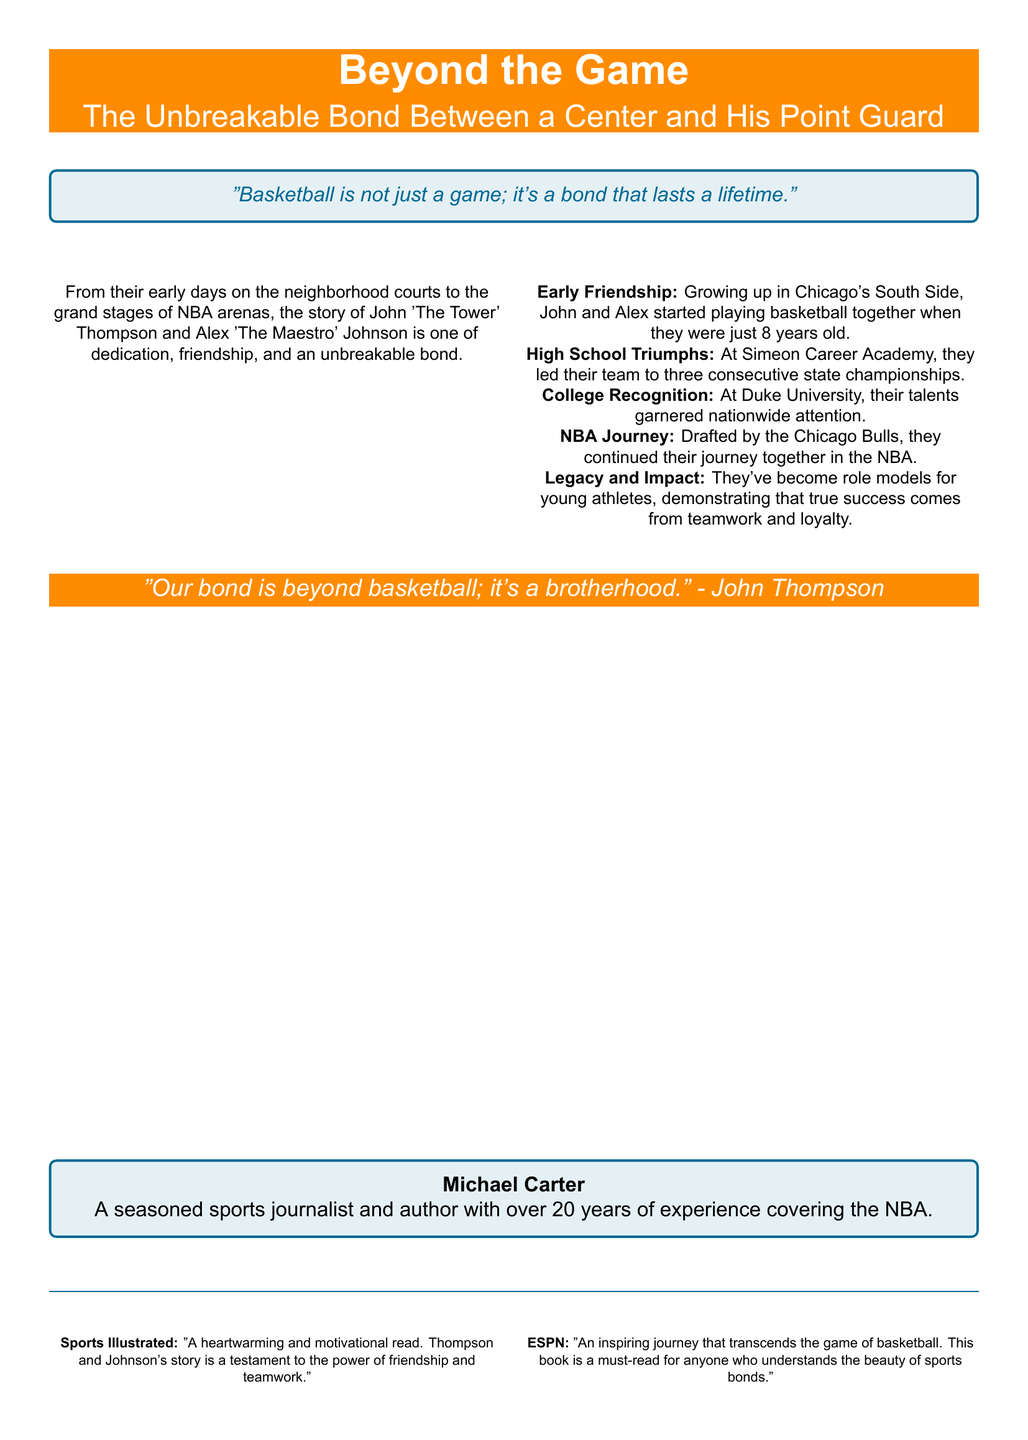What is the title of the book? The title of the book is prominently displayed at the top of the cover.
Answer: Beyond the Game Who are the main subjects of the book? The cover mentions the main subjects as John 'The Tower' Thompson and Alex 'The Maestro' Johnson.
Answer: John 'The Tower' Thompson and Alex 'The Maestro' Johnson At what age did John and Alex start playing basketball together? The document states they started playing when they were just 8 years old.
Answer: 8 years old Which university did they attend together? The document mentions that they attended Duke University.
Answer: Duke University What team were they drafted by? The text notes that they were drafted by the Chicago Bulls.
Answer: Chicago Bulls What quote is attributed to John Thompson? The document includes a quote from John Thompson regarding their bond.
Answer: "Our bond is beyond basketball; it's a brotherhood." Who is the author of the book? The book credits Michael Carter as the author.
Answer: Michael Carter What is the focus of the book according to Sports Illustrated? The review from Sports Illustrated describes the focus of the book as a testament to friendship and teamwork.
Answer: The power of friendship and teamwork How many state championships did they win in high school? The document states they led their team to three consecutive state championships.
Answer: Three 